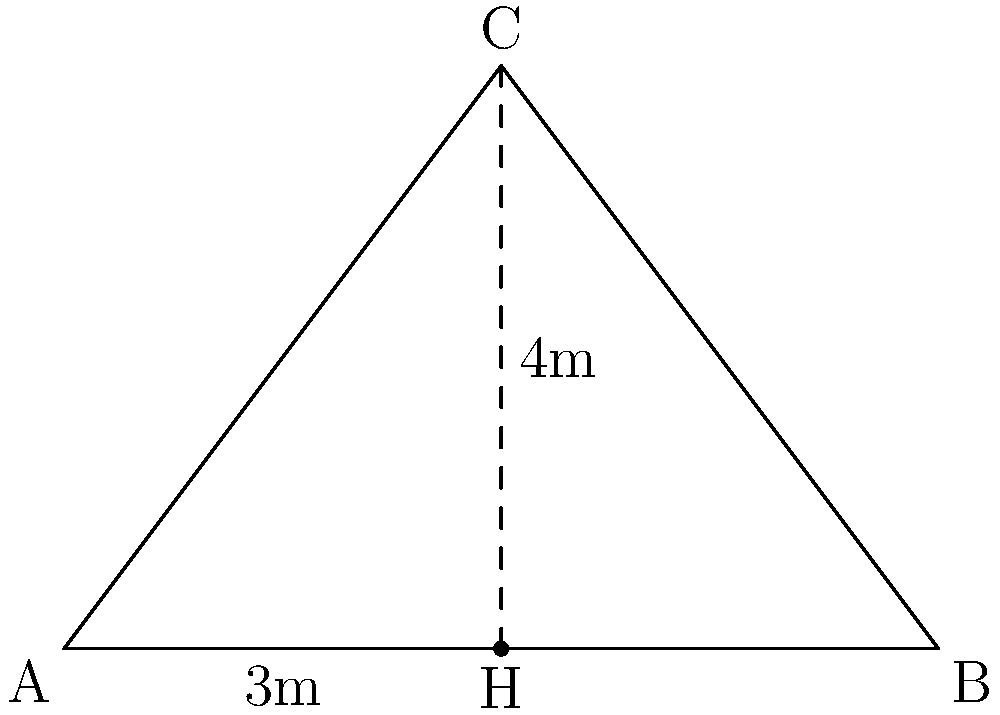In a traditional Japanese-style roof design, the height of the roof peak is 4 meters, and half the width of the building is 3 meters. What is the angle of inclination (in degrees) for this roof design? To find the angle of inclination, we need to use trigonometry. Let's approach this step-by-step:

1) The roof forms a right triangle, where:
   - The height of the roof peak is the opposite side (4 meters)
   - Half the width of the building is the adjacent side (3 meters)
   - The angle we're looking for is the one between the roof and the horizontal

2) We can use the tangent function to find this angle:

   $$\tan(\theta) = \frac{\text{opposite}}{\text{adjacent}} = \frac{4}{3}$$

3) To find the angle, we need to use the inverse tangent (arctan or $\tan^{-1}$):

   $$\theta = \tan^{-1}(\frac{4}{3})$$

4) Using a calculator or computer:

   $$\theta \approx 53.13010235415598^\circ$$

5) Rounding to two decimal places:

   $$\theta \approx 53.13^\circ$$

This angle of approximately 53.13° is typical for many traditional Japanese roof designs, allowing for efficient water runoff and snow shedding in various climate conditions across Japan.
Answer: $53.13^\circ$ 